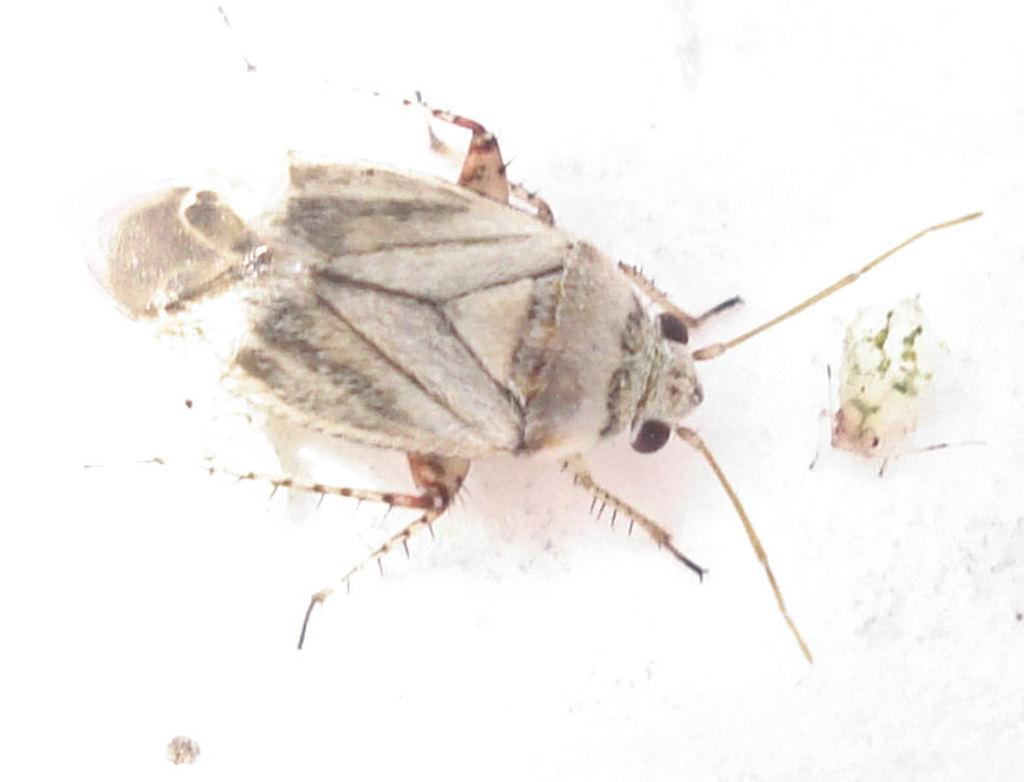What type of creature can be seen in the image? There is an insect in the image. What type of box is the insect using to deliver a shock to its father in the image? There is no box, shock, or father present in the image; it only features an insect. 